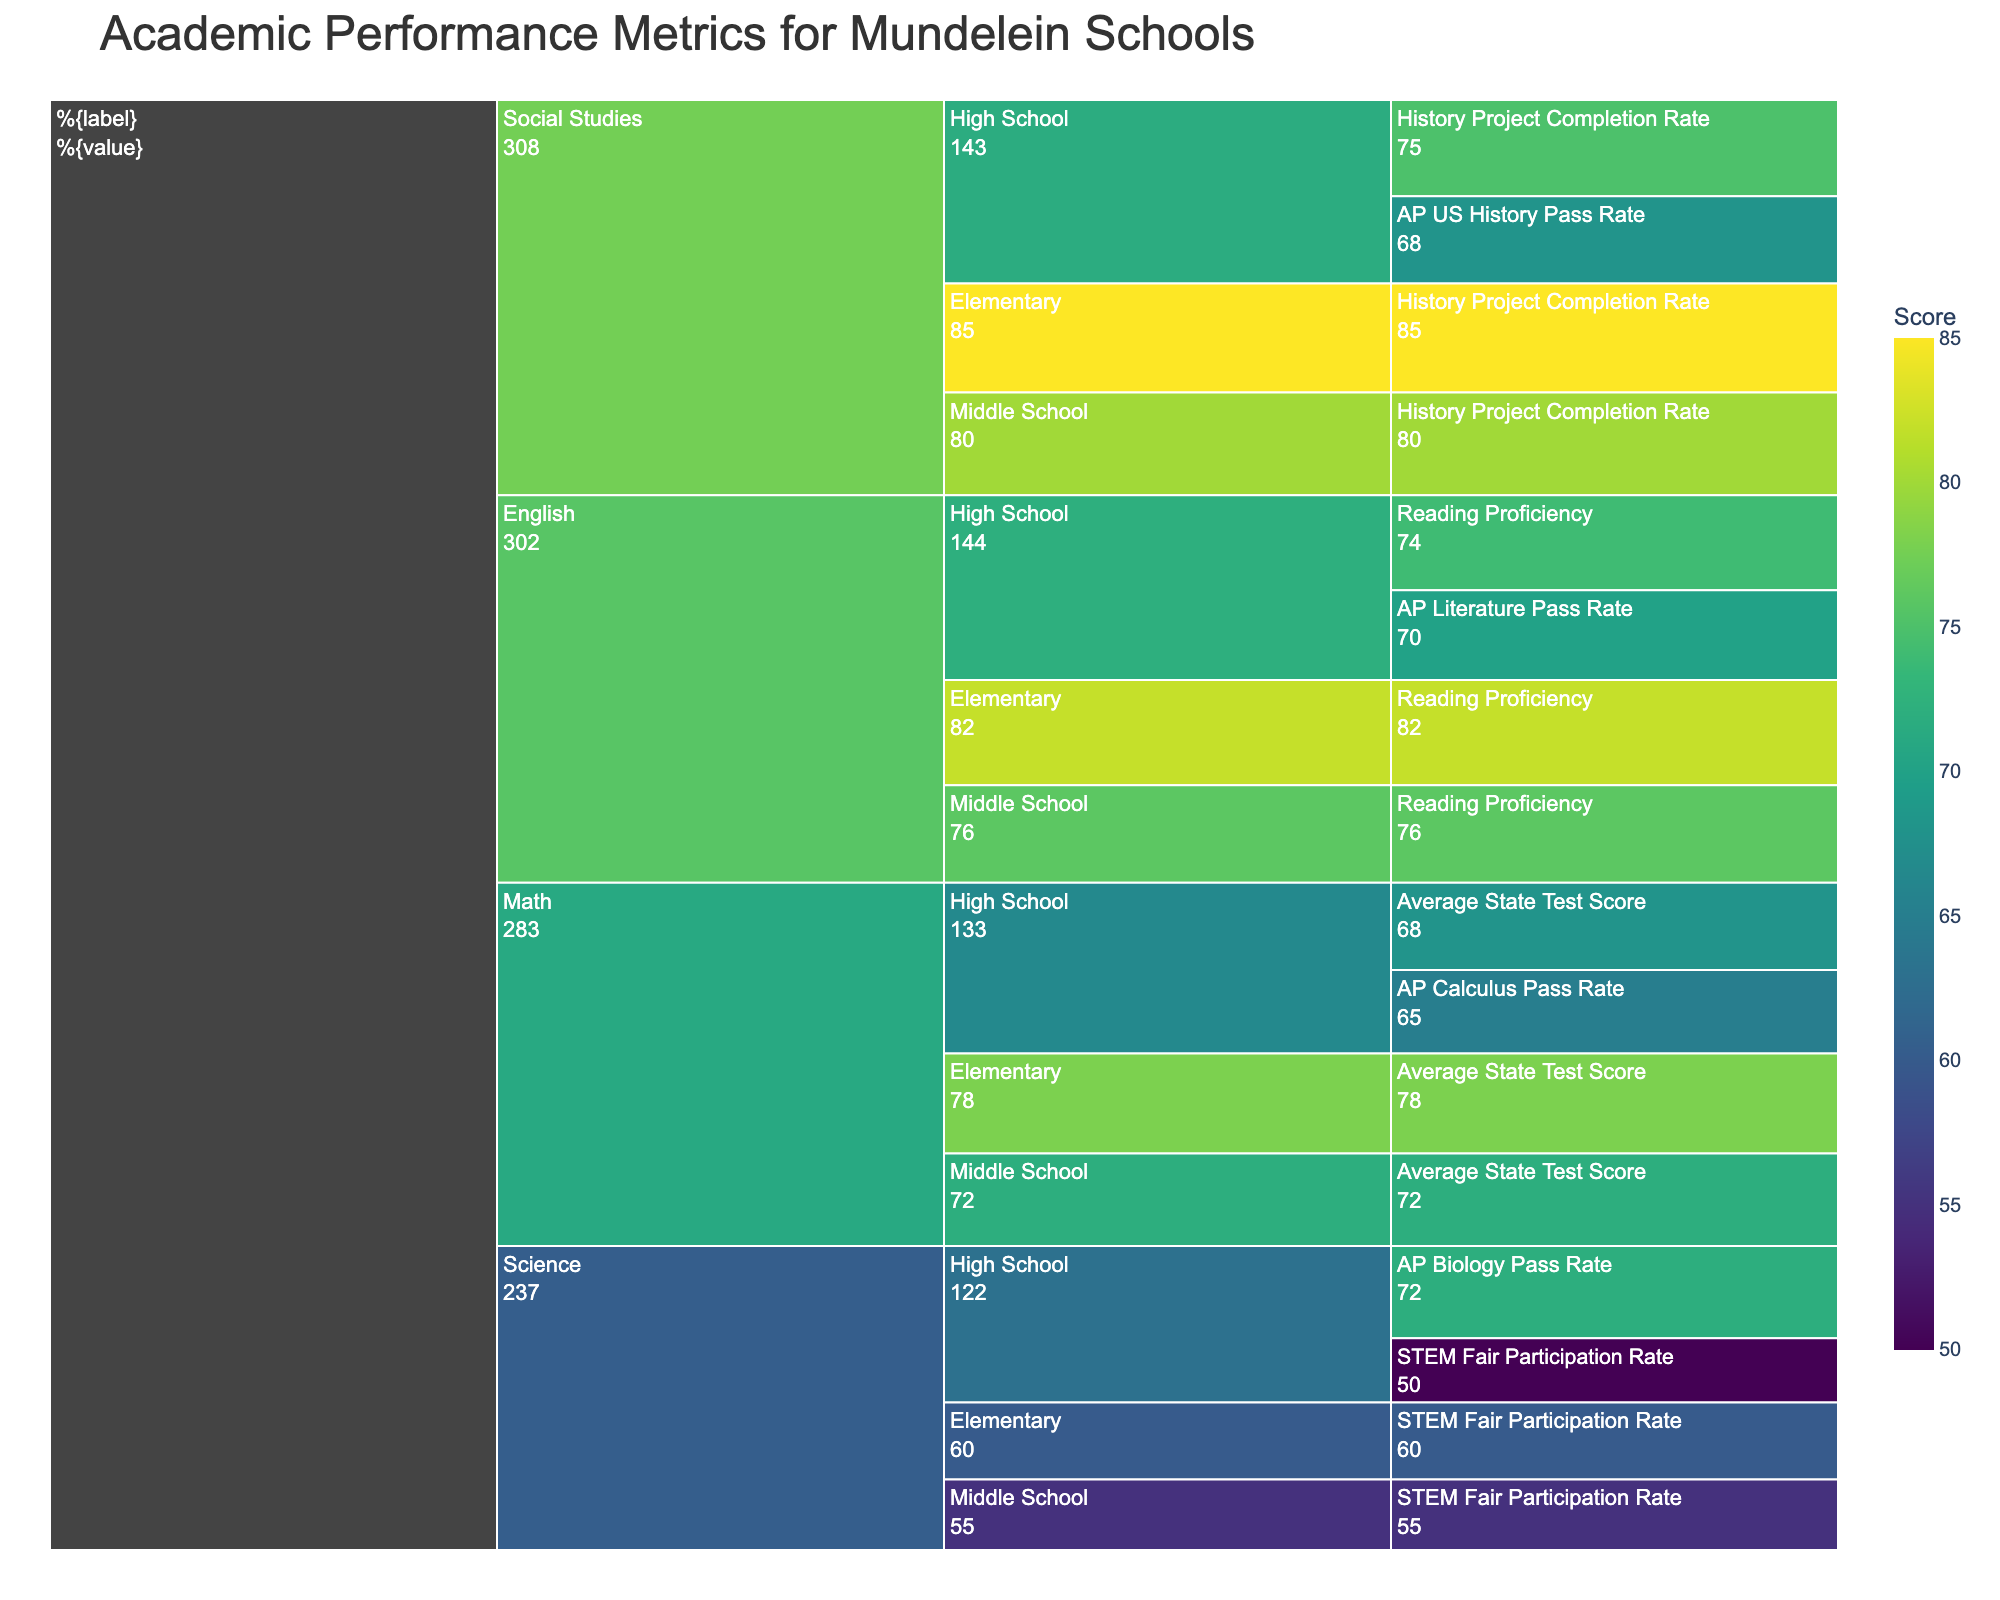What is the title of the figure? The title is visible at the top of the chart. It should be easy to read.
Answer: Academic Performance Metrics for Mundelein Schools Which subject in Elementary grade has the highest performance metric score? Look at the Elementary grade category and compare the scores of different subjects.
Answer: Social Studies What is the difference in the Average State Test Scores between High School and Elementary for Math? Find the Average State Test Score for Math at both High School and Elementary levels and calculate the difference: 78 - 68.
Answer: 10 How does the AP Biology Pass Rate in High School compare to the AP US History Pass Rate in High School? Identify the scores for AP Biology and AP US History in High School. Compare the scores: AP Biology (72), AP US History (68).
Answer: AP Biology is higher Which grade level has the lowest Reading Proficiency score in English? Compare the Reading Proficiency scores across all grades: Elementary (82), Middle School (76), High School (74).
Answer: High School Which metric has the lowest score in Science? Look at all the performance metrics listed under Science and identify the one with the lowest score.
Answer: STEM Fair Participation Rate in High School What is the average score of History Project Completion Rate across all grade levels? Sum the History Project Completion Rates for Elementary, Middle School, and High School, then divide by the number of levels: (85 + 80 + 75) / 3.
Answer: 80 What's the combined score of AP Pass Rates for all subjects in High School? Add the AP Pass Rates for Math (65), English (70), Science (72), and Social Studies (68).
Answer: 275 How does the Reading Proficiency in Middle School English compare to the AP Literature Pass Rate in High School English? Compare the Reading Proficiency score for Middle School English (76) with the AP Literature Pass Rate score in High School English (70).
Answer: Reading Proficiency in Middle School is higher 